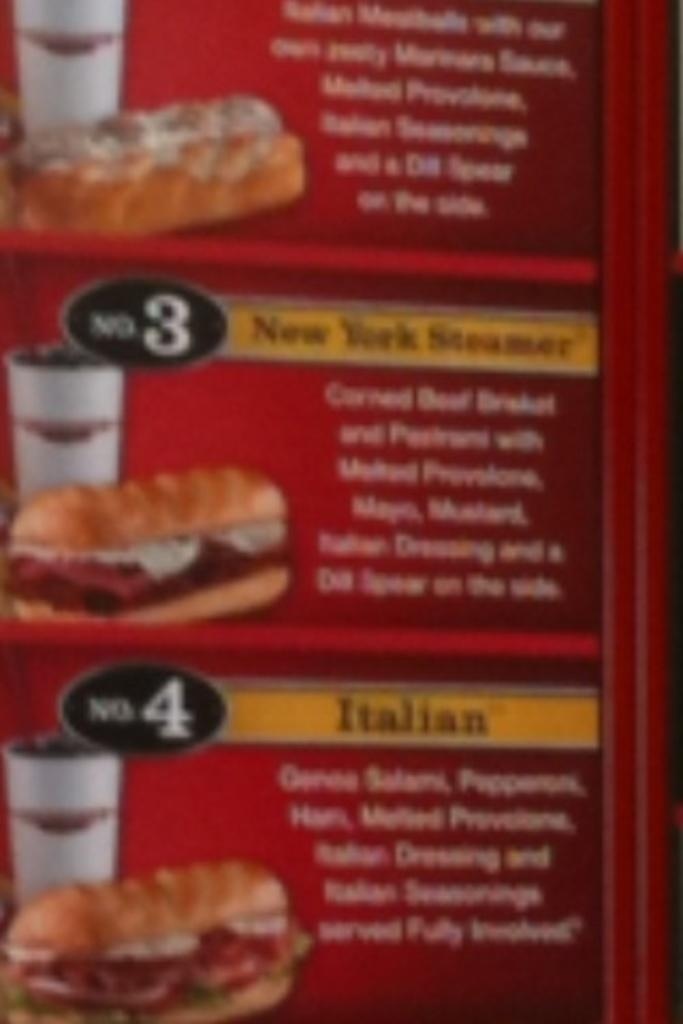What is the primary purpose of the item in the image? The primary purpose of the item in the image is to display a menu of food items. What type of content is present on the menu? The menu contains text and images, including an image of bread and a glass. Can you describe the image of bread on the menu? The menu contains an image of bread, but no specific details about the bread are provided. How does the quince contribute to the digestion process in the image? There is no quince or mention of digestion in the image; it features a menu of food items with text and images. 